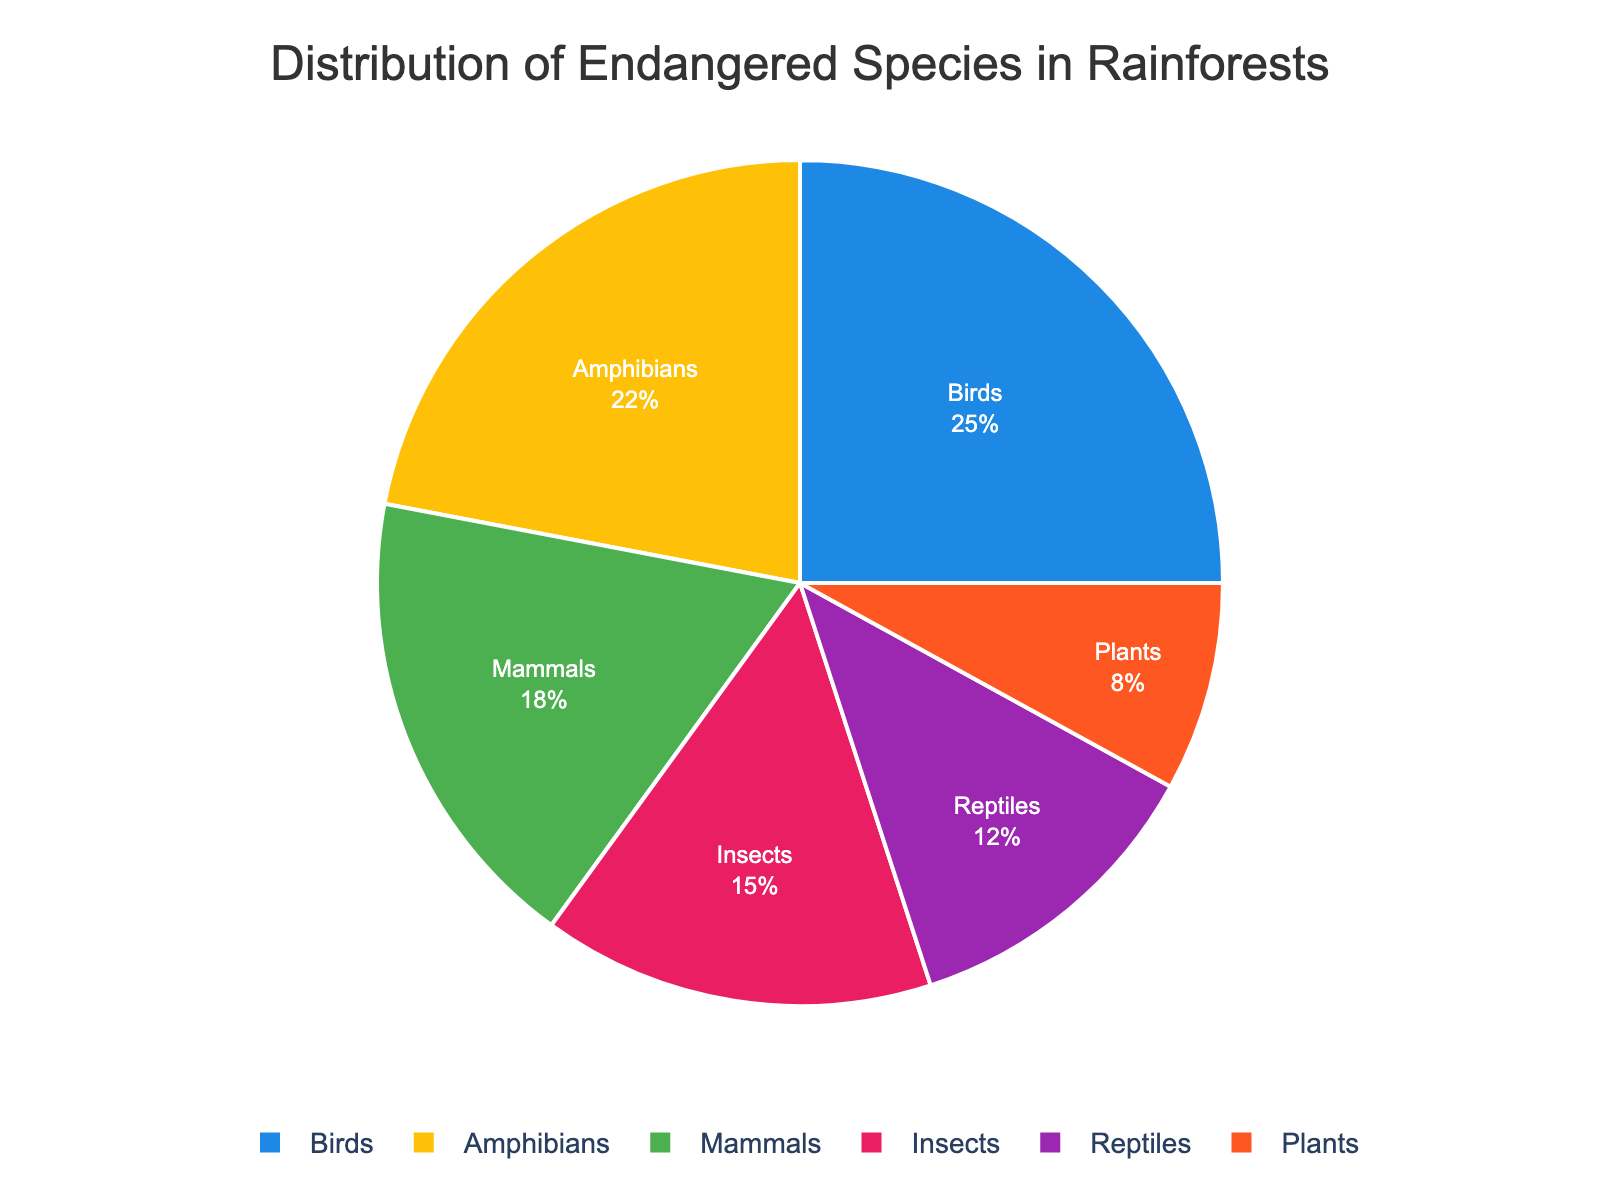What taxonomic group has the highest percentage of endangered species? By looking at the pie chart, we can see that the segment representing birds is the largest, with a percentage of 25%.
Answer: Birds Which two taxonomic groups have the closest percentage of endangered species? The pie chart shows that amphibia have 22% and insects have 15%, which are the closest values in comparison to other pairs.
Answer: Amphibians and Insects What percentage of the total endangered species do reptiles and plants together comprise? To find this, add the percentage of reptiles (12%) and plants (8%): 12 + 8 = 20%.
Answer: 20% What is the difference in percentage between mammals and reptiles? To find the difference, subtract the percentage of reptiles (12%) from the percentage of mammals (18%): 18 - 12 = 6%.
Answer: 6% If we group the species into vertebrates (mammals, birds, amphibians, and reptiles) and invertebrates (insects), and plants, which group has a greater percentage? Add the percentages of vertebrates (18% + 25% + 22% + 12% = 77%) and compare it to the sum of invertebrates and plants (15% + 8% = 23%). Vertebrates have a greater percentage: 77% vs. 23%.
Answer: Vertebrates What taxonomic group is represented by the segment with the color pink? By examining the pie chart, we notice that the pink color segment is labeled as reptiles, representing 12%.
Answer: Reptiles Are the total percentages of amphibians and plants more or less than the percentage of birds? The total percentage of amphibians and plants is 22% (amphibians) + 8% (plants) = 30%, which is greater than 25% (birds).
Answer: More Which taxonomic group represents the smallest percentage of endangered species? By looking at the pie chart, we can see that the plants segment is the smallest, with a percentage of 8%.
Answer: Plants 